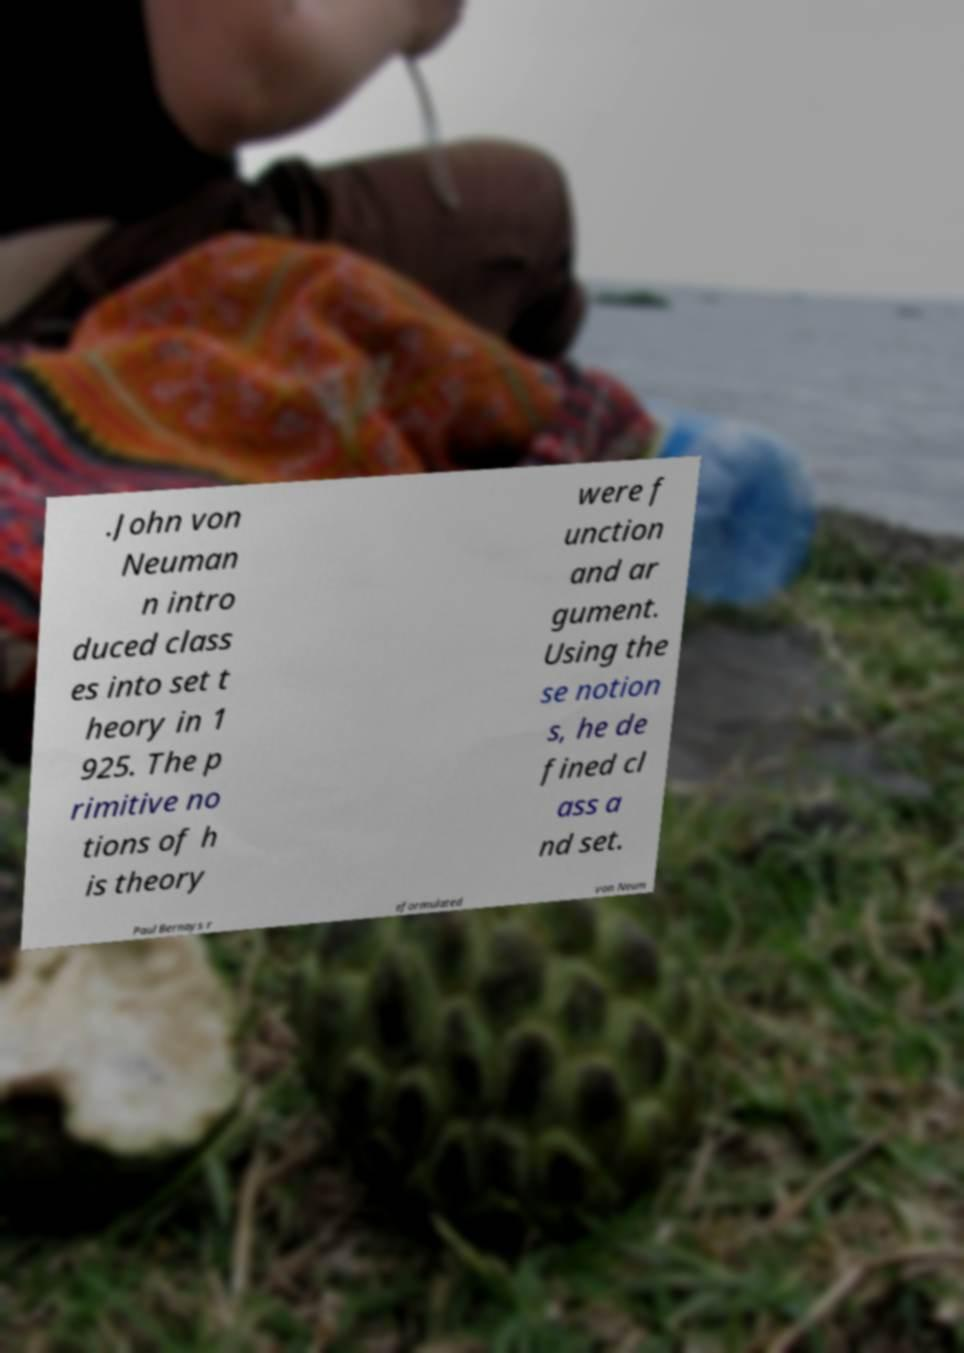I need the written content from this picture converted into text. Can you do that? .John von Neuman n intro duced class es into set t heory in 1 925. The p rimitive no tions of h is theory were f unction and ar gument. Using the se notion s, he de fined cl ass a nd set. Paul Bernays r eformulated von Neum 